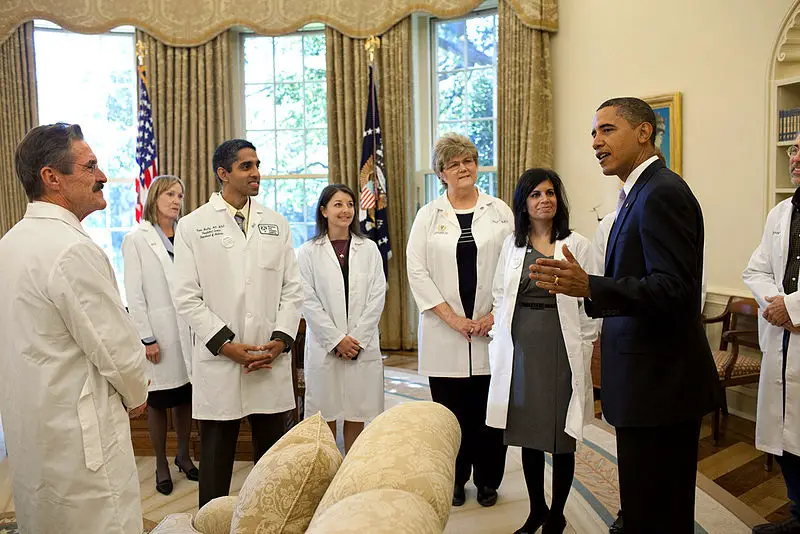What might be the individual in the suit's key concerns in this discussion? The individual in the suit likely has several key concerns, including the efficacy and safety of the proposed medical interventions, the logistical challenges of implementing these solutions on a national scale, and the potential political ramifications. He would also be focused on ensuring that the measures are cost-effective and can be disseminated equitably among the population. Additionally, he may have concerns about public communication strategies to educate and inform the populace about the incoming health measures. How might the dynamics change if one of the medical professionals was a leading expert in a breakthrough medical field? If one of the medical professionals was a leading expert in a breakthrough medical field, the dynamics of the meeting could shift significantly. This individual might take on a more authoritative role, leading the discussion with their expertise and possibly proposing novel solutions that could change the course of the deliberations. Other participants might defer to their judgment more frequently, and their statements could carry more weight in the decision-making process. The presence of such an expert could also elevate the meeting's significance, drawing more attention from media and public stakeholders. 